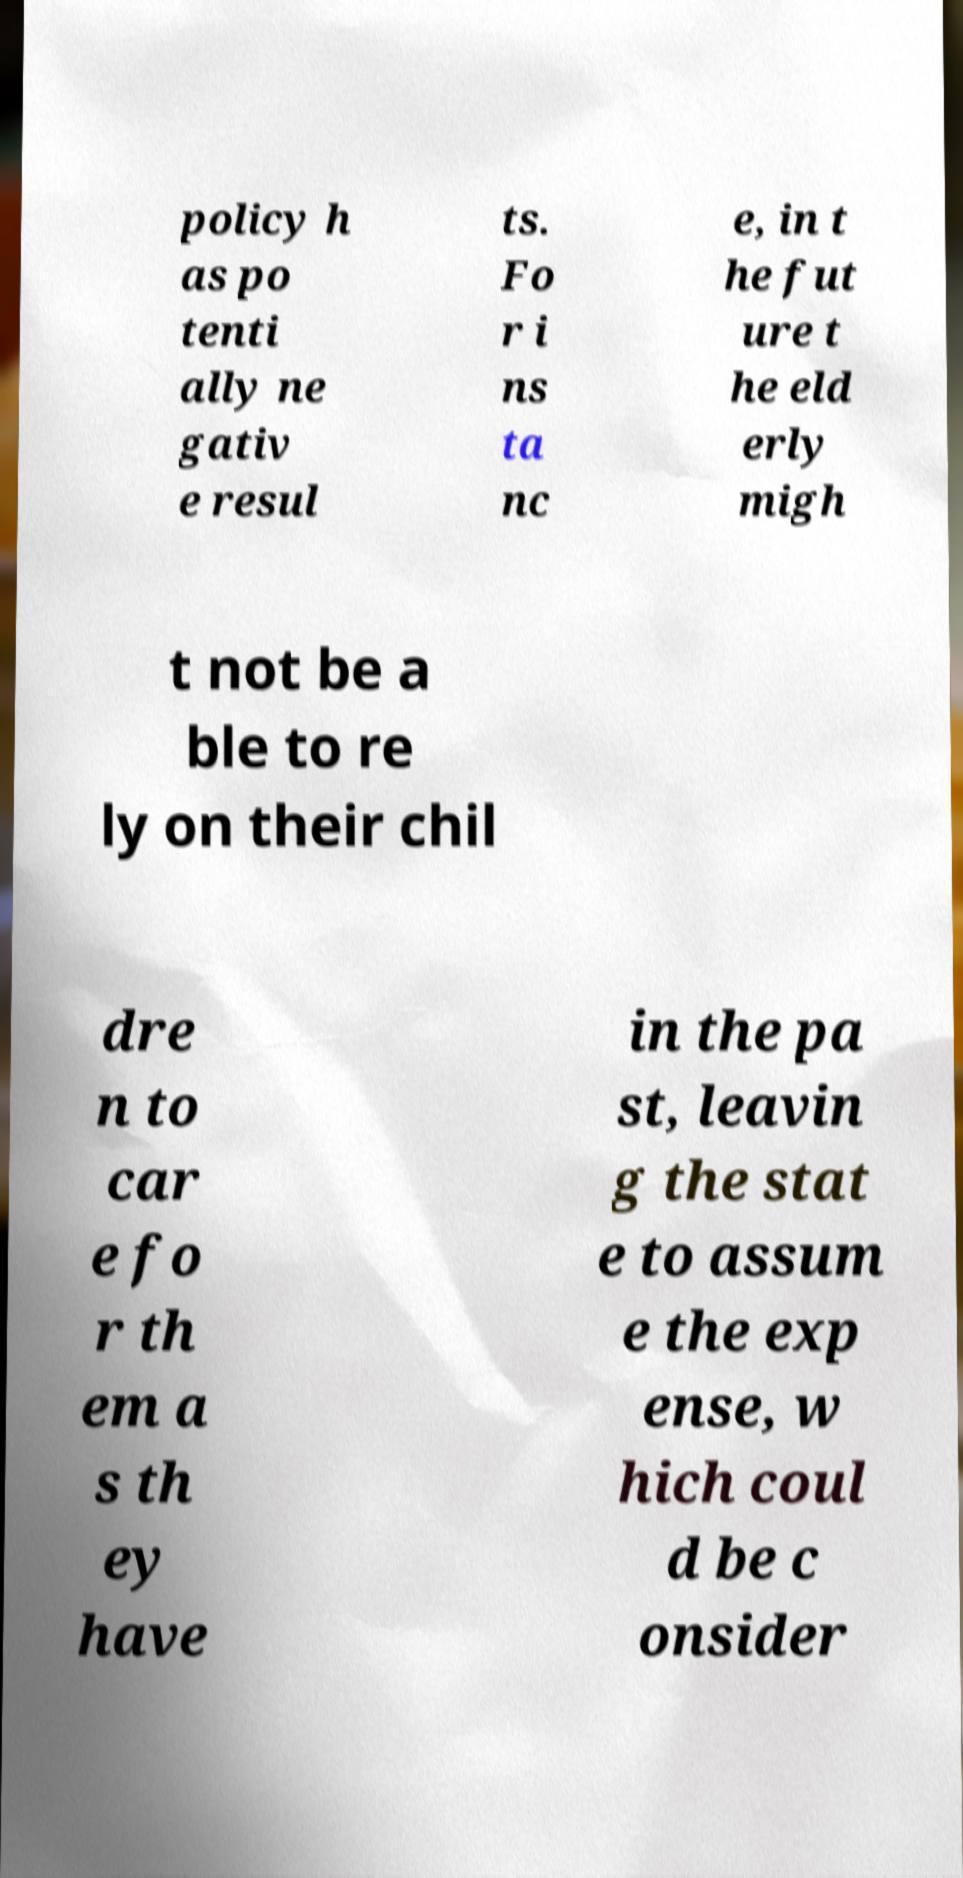Can you accurately transcribe the text from the provided image for me? policy h as po tenti ally ne gativ e resul ts. Fo r i ns ta nc e, in t he fut ure t he eld erly migh t not be a ble to re ly on their chil dre n to car e fo r th em a s th ey have in the pa st, leavin g the stat e to assum e the exp ense, w hich coul d be c onsider 